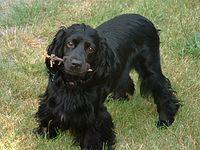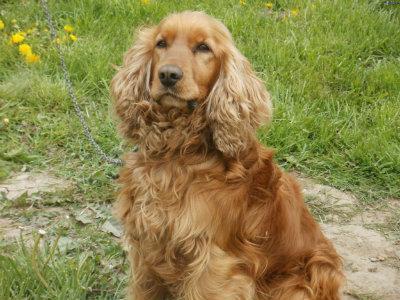The first image is the image on the left, the second image is the image on the right. Assess this claim about the two images: "The brown dogs in the image on the right are sitting outside.". Correct or not? Answer yes or no. Yes. The first image is the image on the left, the second image is the image on the right. Considering the images on both sides, is "The dog in the right image is walking on the grass in profile." valid? Answer yes or no. No. The first image is the image on the left, the second image is the image on the right. Given the left and right images, does the statement "Right image shows at least one golden-haired dog sitting upright." hold true? Answer yes or no. Yes. 